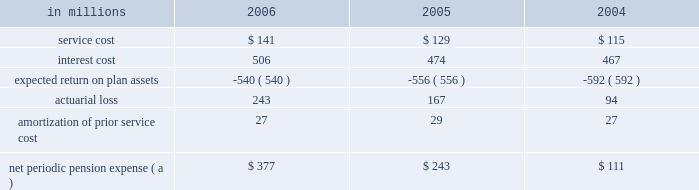Institutions .
International paper continually monitors its positions with and the credit quality of these financial institutions and does not expect non- performance by the counterparties .
Note 14 capital stock the authorized capital stock at both december 31 , 2006 and 2005 , consisted of 990850000 shares of common stock , $ 1 par value ; 400000 shares of cumulative $ 4 preferred stock , without par value ( stated value $ 100 per share ) ; and 8750000 shares of serial preferred stock , $ 1 par value .
The serial preferred stock is issuable in one or more series by the board of directors without further shareholder action .
In july 2006 , in connection with the planned use of projected proceeds from the company 2019s trans- formation plan , international paper 2019s board of direc- tors authorized a share repurchase program to acquire up to $ 3.0 billion of the company 2019s stock .
In a modified 201cdutch auction 201d tender offer completed in september 2006 , international paper purchased 38465260 shares of its common stock at a price of $ 36.00 per share , plus costs to acquire the shares , for a total cost of approximately $ 1.4 billion .
In addition , in december 2006 , the company purchased an addi- tional 1220558 shares of its common stock in the open market at an average price of $ 33.84 per share , plus costs to acquire the shares , for a total cost of approximately $ 41 million .
Following the completion of these share repurchases , international paper had approximately 454 million shares of common stock issued and outstanding .
Note 15 retirement plans u.s .
Defined benefit plans international paper maintains pension plans that provide retirement benefits to substantially all domestic employees hired prior to july 1 , 2004 .
These employees generally are eligible to participate in the plans upon completion of one year of service and attainment of age 21 .
Employees hired after june 30 , 2004 , who are not eligible for these pension plans receive an additional company contribution to their savings plan ( see 201cother plans 201d on page 83 ) .
The plans provide defined benefits based on years of credited service and either final average earnings ( salaried employees ) , hourly job rates or specified benefit rates ( hourly and union employees ) .
For its qualified defined benefit pension plan , interna- tional paper makes contributions that are sufficient to fully fund its actuarially determined costs , gen- erally equal to the minimum amounts required by the employee retirement income security act ( erisa ) .
In addition , international paper made volun- tary contributions of $ 1.0 billion to the qualified defined benefit plan in 2006 , and does not expect to make any contributions in 2007 .
The company also has two unfunded nonqualified defined benefit pension plans : a pension restoration plan available to employees hired prior to july 1 , 2004 that provides retirement benefits based on eligible compensation in excess of limits set by the internal revenue service , and a supplemental retirement plan for senior managers ( serp ) , which is an alternative retirement plan for senior vice presi- dents and above who are designated by the chief executive officer as participants .
These nonqualified plans are only funded to the extent of benefits paid , which are expected to be $ 41 million in 2007 .
Net periodic pension expense service cost is the actuarial present value of benefits attributed by the plans 2019 benefit formula to services rendered by employees during the year .
Interest cost represents the increase in the projected benefit obli- gation , which is a discounted amount , due to the passage of time .
The expected return on plan assets reflects the computed amount of current year earn- ings from the investment of plan assets using an estimated long-term rate of return .
Net periodic pension expense for qualified and nonqualified u.s .
Defined benefit plans comprised the following : in millions 2006 2005 2004 .
( a ) excludes $ 9.1 million , $ 6.5 million and $ 3.4 million in 2006 , 2005 and 2004 , respectively , in curtailment losses , and $ 8.7 million , $ 3.6 million and $ 1.4 million in 2006 , 2005 and 2004 , respectively , of termination benefits , in connection with cost reduction programs and facility rationalizations that were recorded in restructuring and other charges in the con- solidated statement of operations .
Also excludes $ 77.2 million and $ 14.3 million in 2006 and 2005 , respectively , in curtailment losses , and $ 18.6 million and $ 7.6 million of termination bene- fits in 2006 and 2005 , respectively , related to certain divest- itures recorded in net losses on sales and impairments of businesses held for sale in the consolidated statement of oper- ations. .
What is the percentage change in net periodic pension expense between 2005 and 2006? 
Computations: ((377 - 243) / 243)
Answer: 0.55144. 